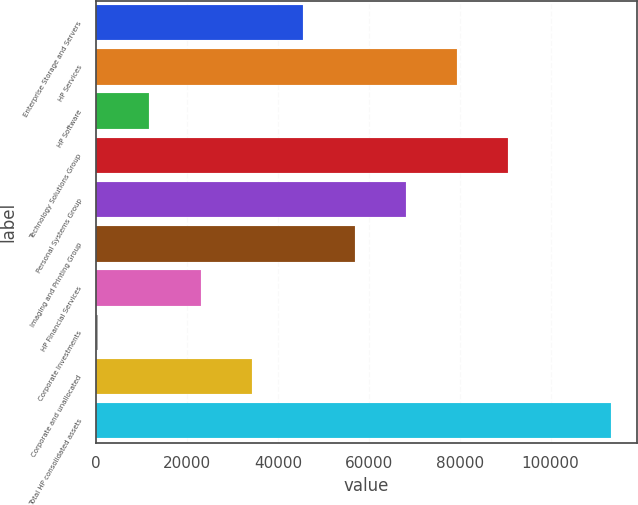Convert chart to OTSL. <chart><loc_0><loc_0><loc_500><loc_500><bar_chart><fcel>Enterprise Storage and Servers<fcel>HP Services<fcel>HP Software<fcel>Technology Solutions Group<fcel>Personal Systems Group<fcel>Imaging and Printing Group<fcel>HP Financial Services<fcel>Corporate Investments<fcel>Corporate and unallocated<fcel>Total HP consolidated assets<nl><fcel>45552<fcel>79441.5<fcel>11662.5<fcel>90738<fcel>68145<fcel>56848.5<fcel>22959<fcel>366<fcel>34255.5<fcel>113331<nl></chart> 